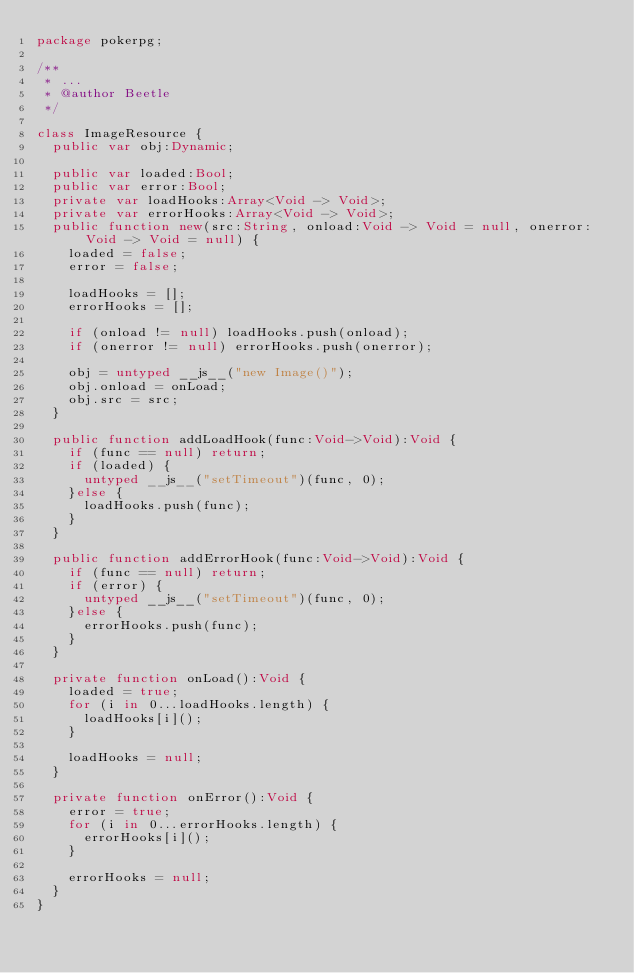<code> <loc_0><loc_0><loc_500><loc_500><_Haxe_>package pokerpg;

/**
 * ...
 * @author Beetle
 */

class ImageResource {
	public var obj:Dynamic;
	
	public var loaded:Bool;
	public var error:Bool;
	private var loadHooks:Array<Void -> Void>;
	private var errorHooks:Array<Void -> Void>;
	public function new(src:String, onload:Void -> Void = null, onerror:Void -> Void = null) {
		loaded = false;
		error = false;
		
		loadHooks = [];
		errorHooks = [];
		
		if (onload != null) loadHooks.push(onload);
		if (onerror != null) errorHooks.push(onerror);
		
		obj = untyped __js__("new Image()");
		obj.onload = onLoad;
		obj.src = src;
	}
	
	public function addLoadHook(func:Void->Void):Void {
		if (func == null) return;
		if (loaded) {
			untyped __js__("setTimeout")(func, 0);
		}else {
			loadHooks.push(func);
		}
	}
	
	public function addErrorHook(func:Void->Void):Void {
		if (func == null) return;
		if (error) {
			untyped __js__("setTimeout")(func, 0);
		}else {
			errorHooks.push(func);
		}
	}
	
	private function onLoad():Void {
		loaded = true;
		for (i in 0...loadHooks.length) {
			loadHooks[i]();
		}
		
		loadHooks = null;
	}
	
	private function onError():Void {
		error = true;
		for (i in 0...errorHooks.length) {
			errorHooks[i]();
		}
		
		errorHooks = null;
	}
}</code> 